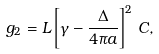<formula> <loc_0><loc_0><loc_500><loc_500>g _ { 2 } = L \left [ \gamma - \frac { \Delta } { 4 \pi a } \right ] ^ { 2 } \, C ,</formula> 